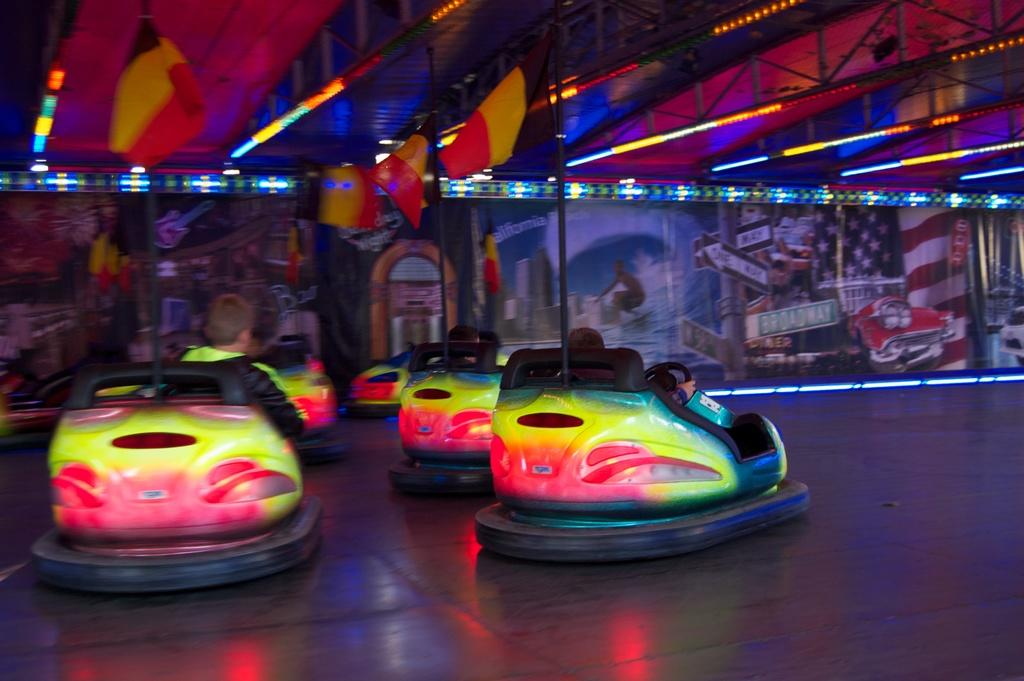What are the people in the image doing? The people in the image are sitting in cars. How are the cars described in the image? The cars are described as "dashing," which could mean they are fast or sporty. What can be seen on the wall in front of the cars? There are graphic images on a wall in front of the cars. What is visible at the top of the image? Metal rods with lights are visible at the top of the image. What type of camera is being used to take a selfie in the image? There is no camera or selfie being taken in the image; it features people sitting in cars with graphic images on a wall in front of them and metal rods with lights at the top. What sound does the bell make in the image? There is no bell present in the image. 